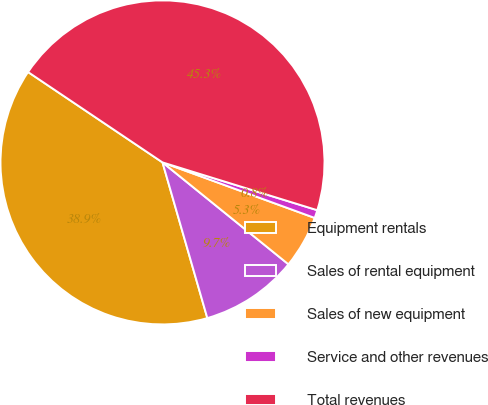Convert chart to OTSL. <chart><loc_0><loc_0><loc_500><loc_500><pie_chart><fcel>Equipment rentals<fcel>Sales of rental equipment<fcel>Sales of new equipment<fcel>Service and other revenues<fcel>Total revenues<nl><fcel>38.88%<fcel>9.71%<fcel>5.26%<fcel>0.8%<fcel>45.35%<nl></chart> 